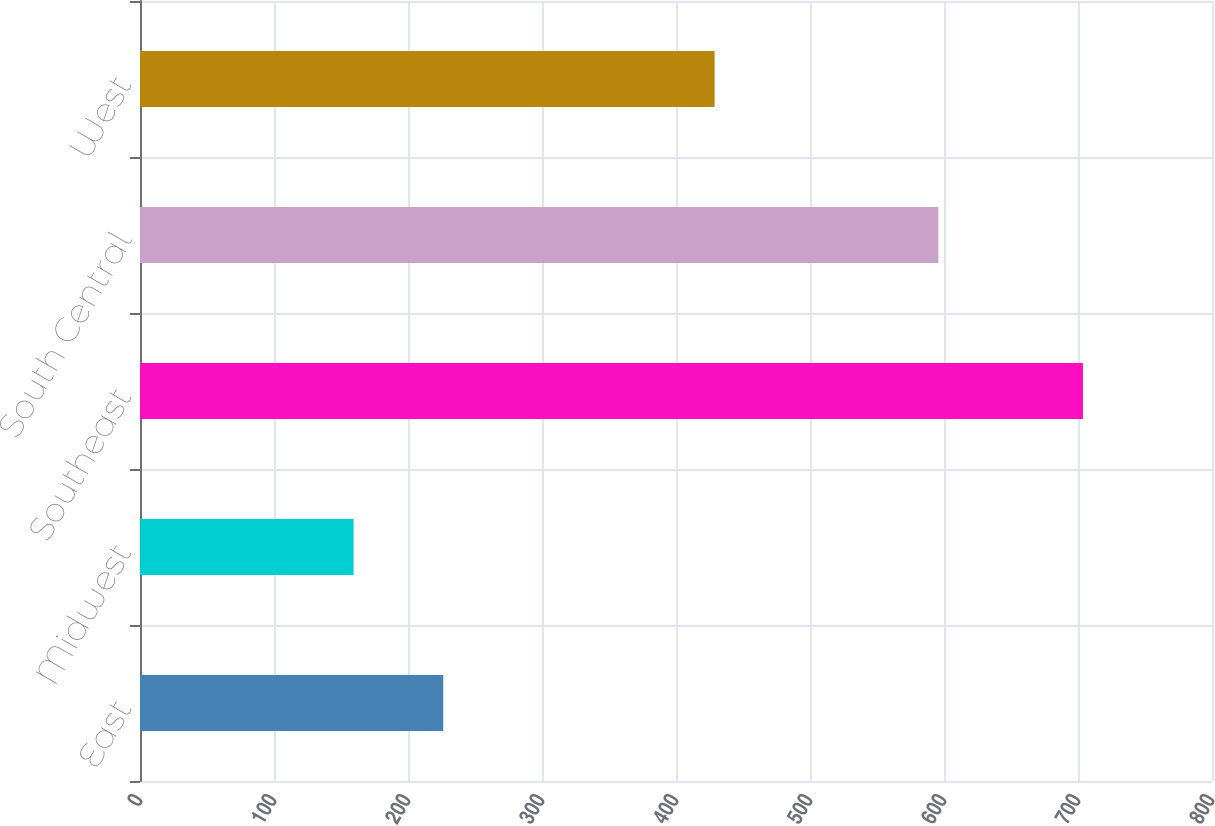Convert chart. <chart><loc_0><loc_0><loc_500><loc_500><bar_chart><fcel>East<fcel>Midwest<fcel>Southeast<fcel>South Central<fcel>West<nl><fcel>226.3<fcel>159.4<fcel>703.7<fcel>595.8<fcel>428.8<nl></chart> 